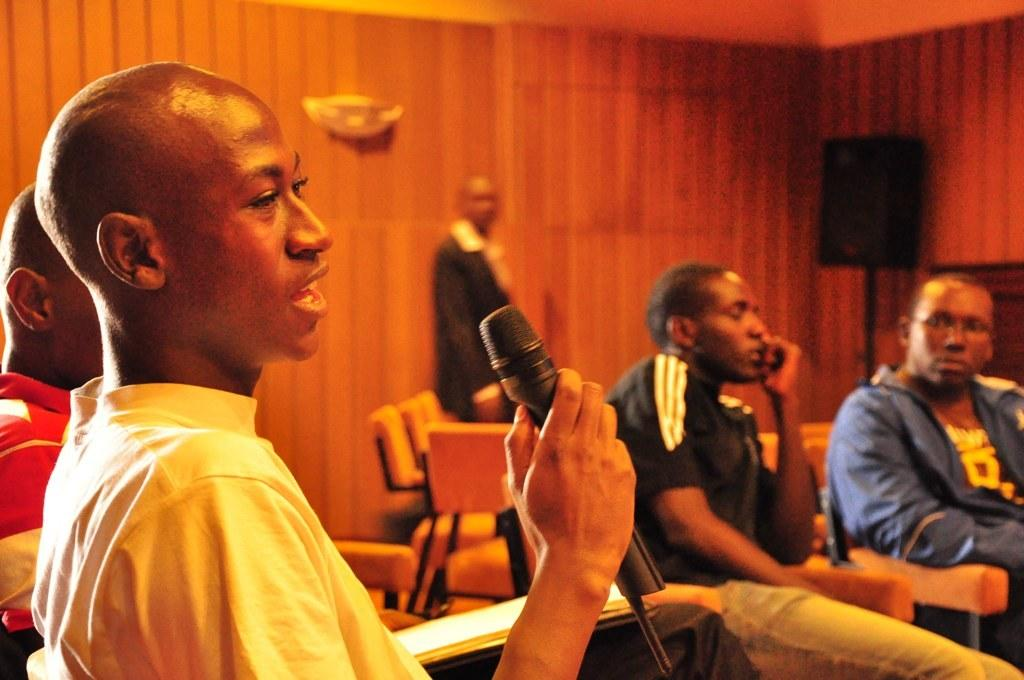What is the main subject of the image? The main subject of the image is a group of African boys. What are the boys doing in the image? The boys are sitting on chairs and singing. What can be seen in the boys' hands in the image? There is a black microphone in the image. What type of wall is visible in the background of the image? There is a wooden panel wall in the background. What other equipment is present in the background of the image? There is a black speaker in the background. Can you tell me how many chess pieces are on the table in the image? There is no table or chess pieces present in the image. What emotion do the boys appear to be expressing while singing in the image? The provided facts do not mention the boys' emotions or expressions while singing. 